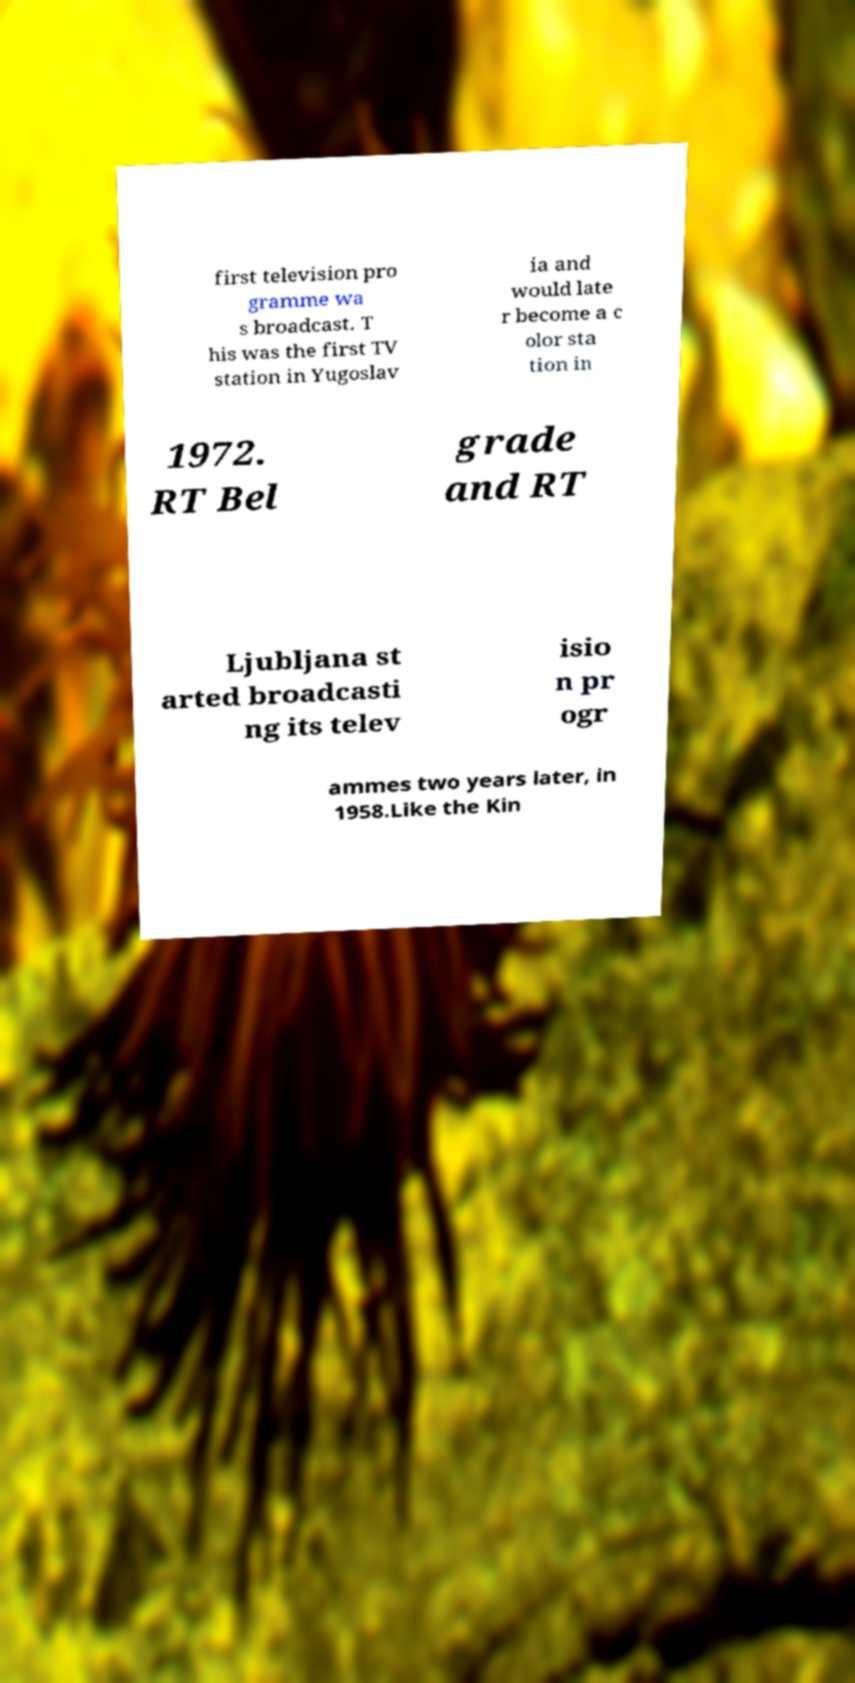What messages or text are displayed in this image? I need them in a readable, typed format. first television pro gramme wa s broadcast. T his was the first TV station in Yugoslav ia and would late r become a c olor sta tion in 1972. RT Bel grade and RT Ljubljana st arted broadcasti ng its telev isio n pr ogr ammes two years later, in 1958.Like the Kin 